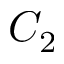<formula> <loc_0><loc_0><loc_500><loc_500>C _ { 2 }</formula> 